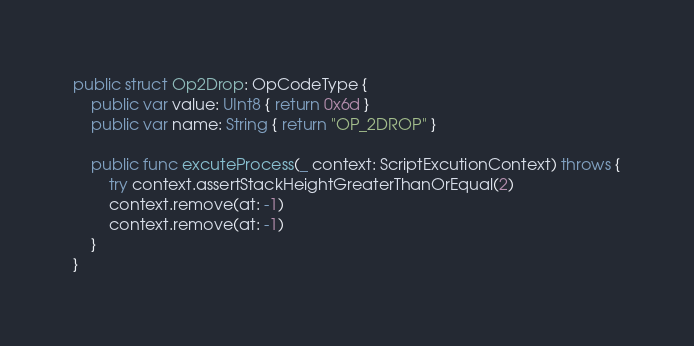<code> <loc_0><loc_0><loc_500><loc_500><_Swift_>
public struct Op2Drop: OpCodeType {
    public var value: UInt8 { return 0x6d }
    public var name: String { return "OP_2DROP" }
    
    public func excuteProcess(_ context: ScriptExcutionContext) throws {
        try context.assertStackHeightGreaterThanOrEqual(2)
        context.remove(at: -1)
        context.remove(at: -1)
    }
}
</code> 